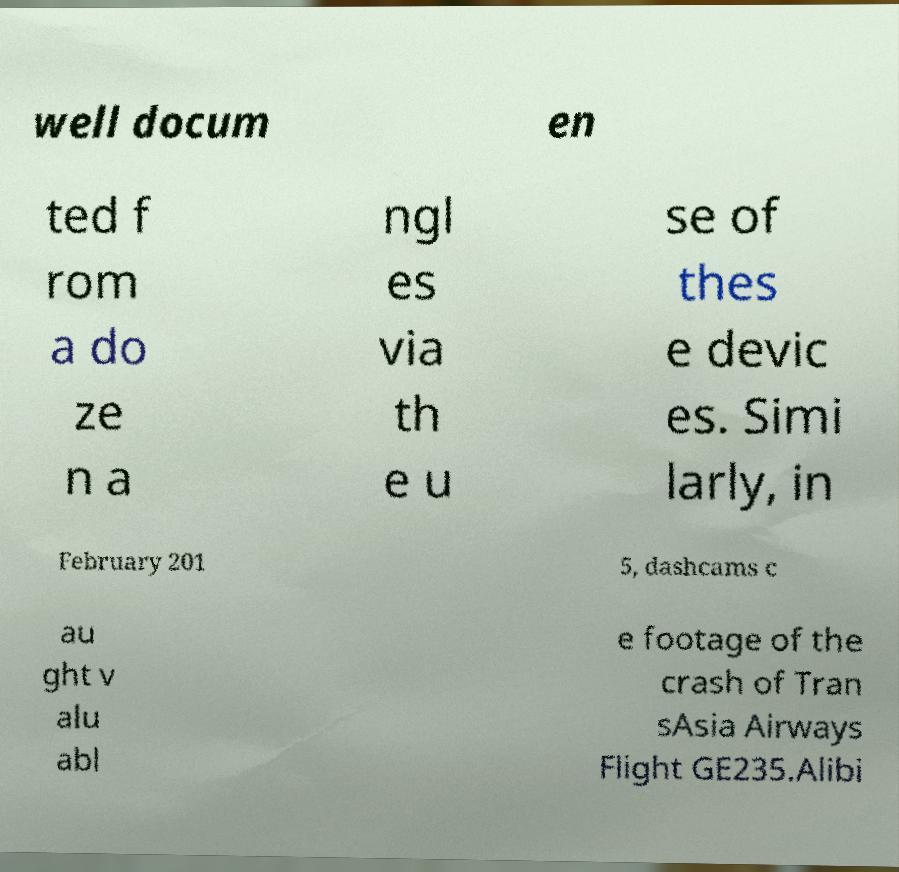Could you extract and type out the text from this image? well docum en ted f rom a do ze n a ngl es via th e u se of thes e devic es. Simi larly, in February 201 5, dashcams c au ght v alu abl e footage of the crash of Tran sAsia Airways Flight GE235.Alibi 